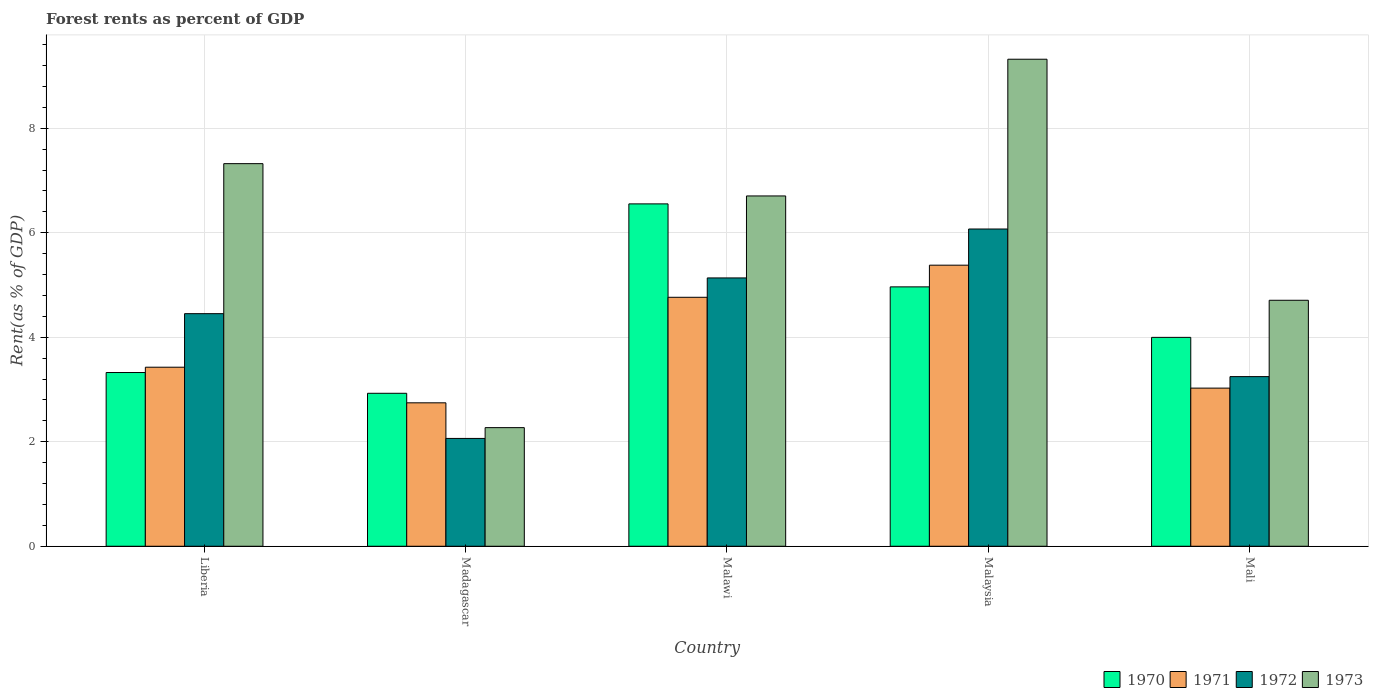Are the number of bars per tick equal to the number of legend labels?
Provide a short and direct response. Yes. What is the label of the 3rd group of bars from the left?
Provide a succinct answer. Malawi. What is the forest rent in 1970 in Madagascar?
Your response must be concise. 2.93. Across all countries, what is the maximum forest rent in 1972?
Provide a succinct answer. 6.07. Across all countries, what is the minimum forest rent in 1970?
Offer a very short reply. 2.93. In which country was the forest rent in 1970 maximum?
Keep it short and to the point. Malawi. In which country was the forest rent in 1973 minimum?
Give a very brief answer. Madagascar. What is the total forest rent in 1972 in the graph?
Ensure brevity in your answer.  20.97. What is the difference between the forest rent in 1972 in Liberia and that in Malaysia?
Provide a short and direct response. -1.62. What is the difference between the forest rent in 1972 in Liberia and the forest rent in 1971 in Malaysia?
Your response must be concise. -0.93. What is the average forest rent in 1971 per country?
Offer a terse response. 3.87. What is the difference between the forest rent of/in 1973 and forest rent of/in 1972 in Malaysia?
Offer a terse response. 3.25. In how many countries, is the forest rent in 1971 greater than 3.2 %?
Ensure brevity in your answer.  3. What is the ratio of the forest rent in 1972 in Madagascar to that in Malaysia?
Your answer should be very brief. 0.34. What is the difference between the highest and the second highest forest rent in 1973?
Give a very brief answer. 2.62. What is the difference between the highest and the lowest forest rent in 1971?
Your answer should be compact. 2.63. In how many countries, is the forest rent in 1972 greater than the average forest rent in 1972 taken over all countries?
Keep it short and to the point. 3. Is the sum of the forest rent in 1970 in Liberia and Madagascar greater than the maximum forest rent in 1973 across all countries?
Keep it short and to the point. No. Is it the case that in every country, the sum of the forest rent in 1971 and forest rent in 1970 is greater than the sum of forest rent in 1973 and forest rent in 1972?
Ensure brevity in your answer.  No. What does the 3rd bar from the left in Malawi represents?
Your response must be concise. 1972. Is it the case that in every country, the sum of the forest rent in 1973 and forest rent in 1970 is greater than the forest rent in 1971?
Your response must be concise. Yes. How many countries are there in the graph?
Provide a short and direct response. 5. What is the difference between two consecutive major ticks on the Y-axis?
Make the answer very short. 2. Are the values on the major ticks of Y-axis written in scientific E-notation?
Your answer should be compact. No. Does the graph contain any zero values?
Provide a succinct answer. No. How many legend labels are there?
Your answer should be compact. 4. How are the legend labels stacked?
Keep it short and to the point. Horizontal. What is the title of the graph?
Offer a terse response. Forest rents as percent of GDP. Does "1982" appear as one of the legend labels in the graph?
Your response must be concise. No. What is the label or title of the X-axis?
Your response must be concise. Country. What is the label or title of the Y-axis?
Your answer should be very brief. Rent(as % of GDP). What is the Rent(as % of GDP) in 1970 in Liberia?
Provide a short and direct response. 3.33. What is the Rent(as % of GDP) of 1971 in Liberia?
Give a very brief answer. 3.43. What is the Rent(as % of GDP) in 1972 in Liberia?
Ensure brevity in your answer.  4.45. What is the Rent(as % of GDP) in 1973 in Liberia?
Your response must be concise. 7.32. What is the Rent(as % of GDP) in 1970 in Madagascar?
Your answer should be very brief. 2.93. What is the Rent(as % of GDP) of 1971 in Madagascar?
Ensure brevity in your answer.  2.75. What is the Rent(as % of GDP) of 1972 in Madagascar?
Offer a terse response. 2.06. What is the Rent(as % of GDP) in 1973 in Madagascar?
Your answer should be compact. 2.27. What is the Rent(as % of GDP) in 1970 in Malawi?
Ensure brevity in your answer.  6.55. What is the Rent(as % of GDP) of 1971 in Malawi?
Give a very brief answer. 4.77. What is the Rent(as % of GDP) of 1972 in Malawi?
Offer a terse response. 5.14. What is the Rent(as % of GDP) in 1973 in Malawi?
Offer a very short reply. 6.71. What is the Rent(as % of GDP) of 1970 in Malaysia?
Make the answer very short. 4.96. What is the Rent(as % of GDP) in 1971 in Malaysia?
Your response must be concise. 5.38. What is the Rent(as % of GDP) in 1972 in Malaysia?
Your response must be concise. 6.07. What is the Rent(as % of GDP) in 1973 in Malaysia?
Give a very brief answer. 9.32. What is the Rent(as % of GDP) in 1970 in Mali?
Give a very brief answer. 4. What is the Rent(as % of GDP) in 1971 in Mali?
Keep it short and to the point. 3.03. What is the Rent(as % of GDP) in 1972 in Mali?
Your answer should be very brief. 3.25. What is the Rent(as % of GDP) of 1973 in Mali?
Make the answer very short. 4.71. Across all countries, what is the maximum Rent(as % of GDP) of 1970?
Keep it short and to the point. 6.55. Across all countries, what is the maximum Rent(as % of GDP) in 1971?
Keep it short and to the point. 5.38. Across all countries, what is the maximum Rent(as % of GDP) in 1972?
Your response must be concise. 6.07. Across all countries, what is the maximum Rent(as % of GDP) in 1973?
Keep it short and to the point. 9.32. Across all countries, what is the minimum Rent(as % of GDP) in 1970?
Your answer should be compact. 2.93. Across all countries, what is the minimum Rent(as % of GDP) of 1971?
Your answer should be compact. 2.75. Across all countries, what is the minimum Rent(as % of GDP) in 1972?
Provide a succinct answer. 2.06. Across all countries, what is the minimum Rent(as % of GDP) of 1973?
Give a very brief answer. 2.27. What is the total Rent(as % of GDP) in 1970 in the graph?
Provide a short and direct response. 21.77. What is the total Rent(as % of GDP) in 1971 in the graph?
Offer a very short reply. 19.34. What is the total Rent(as % of GDP) of 1972 in the graph?
Offer a terse response. 20.97. What is the total Rent(as % of GDP) of 1973 in the graph?
Give a very brief answer. 30.33. What is the difference between the Rent(as % of GDP) of 1970 in Liberia and that in Madagascar?
Your answer should be compact. 0.4. What is the difference between the Rent(as % of GDP) of 1971 in Liberia and that in Madagascar?
Offer a terse response. 0.68. What is the difference between the Rent(as % of GDP) in 1972 in Liberia and that in Madagascar?
Offer a very short reply. 2.39. What is the difference between the Rent(as % of GDP) of 1973 in Liberia and that in Madagascar?
Give a very brief answer. 5.05. What is the difference between the Rent(as % of GDP) in 1970 in Liberia and that in Malawi?
Your answer should be very brief. -3.23. What is the difference between the Rent(as % of GDP) of 1971 in Liberia and that in Malawi?
Ensure brevity in your answer.  -1.34. What is the difference between the Rent(as % of GDP) in 1972 in Liberia and that in Malawi?
Provide a succinct answer. -0.68. What is the difference between the Rent(as % of GDP) in 1973 in Liberia and that in Malawi?
Provide a short and direct response. 0.62. What is the difference between the Rent(as % of GDP) of 1970 in Liberia and that in Malaysia?
Keep it short and to the point. -1.64. What is the difference between the Rent(as % of GDP) in 1971 in Liberia and that in Malaysia?
Offer a terse response. -1.95. What is the difference between the Rent(as % of GDP) of 1972 in Liberia and that in Malaysia?
Your response must be concise. -1.62. What is the difference between the Rent(as % of GDP) in 1973 in Liberia and that in Malaysia?
Your response must be concise. -2. What is the difference between the Rent(as % of GDP) in 1970 in Liberia and that in Mali?
Give a very brief answer. -0.67. What is the difference between the Rent(as % of GDP) in 1971 in Liberia and that in Mali?
Your answer should be compact. 0.4. What is the difference between the Rent(as % of GDP) in 1972 in Liberia and that in Mali?
Your response must be concise. 1.21. What is the difference between the Rent(as % of GDP) of 1973 in Liberia and that in Mali?
Your response must be concise. 2.62. What is the difference between the Rent(as % of GDP) of 1970 in Madagascar and that in Malawi?
Offer a very short reply. -3.63. What is the difference between the Rent(as % of GDP) of 1971 in Madagascar and that in Malawi?
Your answer should be compact. -2.02. What is the difference between the Rent(as % of GDP) of 1972 in Madagascar and that in Malawi?
Your answer should be compact. -3.07. What is the difference between the Rent(as % of GDP) in 1973 in Madagascar and that in Malawi?
Provide a succinct answer. -4.43. What is the difference between the Rent(as % of GDP) in 1970 in Madagascar and that in Malaysia?
Ensure brevity in your answer.  -2.04. What is the difference between the Rent(as % of GDP) of 1971 in Madagascar and that in Malaysia?
Provide a short and direct response. -2.63. What is the difference between the Rent(as % of GDP) in 1972 in Madagascar and that in Malaysia?
Offer a very short reply. -4.01. What is the difference between the Rent(as % of GDP) of 1973 in Madagascar and that in Malaysia?
Keep it short and to the point. -7.05. What is the difference between the Rent(as % of GDP) of 1970 in Madagascar and that in Mali?
Offer a very short reply. -1.07. What is the difference between the Rent(as % of GDP) of 1971 in Madagascar and that in Mali?
Offer a very short reply. -0.28. What is the difference between the Rent(as % of GDP) in 1972 in Madagascar and that in Mali?
Your answer should be compact. -1.18. What is the difference between the Rent(as % of GDP) in 1973 in Madagascar and that in Mali?
Keep it short and to the point. -2.44. What is the difference between the Rent(as % of GDP) of 1970 in Malawi and that in Malaysia?
Make the answer very short. 1.59. What is the difference between the Rent(as % of GDP) in 1971 in Malawi and that in Malaysia?
Provide a succinct answer. -0.61. What is the difference between the Rent(as % of GDP) in 1972 in Malawi and that in Malaysia?
Provide a succinct answer. -0.94. What is the difference between the Rent(as % of GDP) in 1973 in Malawi and that in Malaysia?
Make the answer very short. -2.62. What is the difference between the Rent(as % of GDP) of 1970 in Malawi and that in Mali?
Offer a terse response. 2.55. What is the difference between the Rent(as % of GDP) in 1971 in Malawi and that in Mali?
Offer a terse response. 1.74. What is the difference between the Rent(as % of GDP) of 1972 in Malawi and that in Mali?
Give a very brief answer. 1.89. What is the difference between the Rent(as % of GDP) in 1973 in Malawi and that in Mali?
Keep it short and to the point. 2. What is the difference between the Rent(as % of GDP) of 1970 in Malaysia and that in Mali?
Give a very brief answer. 0.97. What is the difference between the Rent(as % of GDP) in 1971 in Malaysia and that in Mali?
Provide a short and direct response. 2.35. What is the difference between the Rent(as % of GDP) in 1972 in Malaysia and that in Mali?
Ensure brevity in your answer.  2.83. What is the difference between the Rent(as % of GDP) in 1973 in Malaysia and that in Mali?
Provide a succinct answer. 4.61. What is the difference between the Rent(as % of GDP) of 1970 in Liberia and the Rent(as % of GDP) of 1971 in Madagascar?
Your answer should be compact. 0.58. What is the difference between the Rent(as % of GDP) in 1970 in Liberia and the Rent(as % of GDP) in 1972 in Madagascar?
Make the answer very short. 1.26. What is the difference between the Rent(as % of GDP) in 1970 in Liberia and the Rent(as % of GDP) in 1973 in Madagascar?
Provide a short and direct response. 1.05. What is the difference between the Rent(as % of GDP) in 1971 in Liberia and the Rent(as % of GDP) in 1972 in Madagascar?
Provide a succinct answer. 1.36. What is the difference between the Rent(as % of GDP) of 1971 in Liberia and the Rent(as % of GDP) of 1973 in Madagascar?
Your answer should be compact. 1.16. What is the difference between the Rent(as % of GDP) in 1972 in Liberia and the Rent(as % of GDP) in 1973 in Madagascar?
Provide a succinct answer. 2.18. What is the difference between the Rent(as % of GDP) of 1970 in Liberia and the Rent(as % of GDP) of 1971 in Malawi?
Provide a short and direct response. -1.44. What is the difference between the Rent(as % of GDP) of 1970 in Liberia and the Rent(as % of GDP) of 1972 in Malawi?
Your response must be concise. -1.81. What is the difference between the Rent(as % of GDP) of 1970 in Liberia and the Rent(as % of GDP) of 1973 in Malawi?
Your response must be concise. -3.38. What is the difference between the Rent(as % of GDP) of 1971 in Liberia and the Rent(as % of GDP) of 1972 in Malawi?
Offer a very short reply. -1.71. What is the difference between the Rent(as % of GDP) of 1971 in Liberia and the Rent(as % of GDP) of 1973 in Malawi?
Provide a succinct answer. -3.28. What is the difference between the Rent(as % of GDP) in 1972 in Liberia and the Rent(as % of GDP) in 1973 in Malawi?
Your answer should be compact. -2.25. What is the difference between the Rent(as % of GDP) of 1970 in Liberia and the Rent(as % of GDP) of 1971 in Malaysia?
Keep it short and to the point. -2.05. What is the difference between the Rent(as % of GDP) in 1970 in Liberia and the Rent(as % of GDP) in 1972 in Malaysia?
Offer a terse response. -2.75. What is the difference between the Rent(as % of GDP) of 1970 in Liberia and the Rent(as % of GDP) of 1973 in Malaysia?
Keep it short and to the point. -6. What is the difference between the Rent(as % of GDP) in 1971 in Liberia and the Rent(as % of GDP) in 1972 in Malaysia?
Provide a succinct answer. -2.65. What is the difference between the Rent(as % of GDP) of 1971 in Liberia and the Rent(as % of GDP) of 1973 in Malaysia?
Provide a succinct answer. -5.89. What is the difference between the Rent(as % of GDP) in 1972 in Liberia and the Rent(as % of GDP) in 1973 in Malaysia?
Give a very brief answer. -4.87. What is the difference between the Rent(as % of GDP) in 1970 in Liberia and the Rent(as % of GDP) in 1971 in Mali?
Ensure brevity in your answer.  0.3. What is the difference between the Rent(as % of GDP) in 1970 in Liberia and the Rent(as % of GDP) in 1972 in Mali?
Your answer should be very brief. 0.08. What is the difference between the Rent(as % of GDP) of 1970 in Liberia and the Rent(as % of GDP) of 1973 in Mali?
Your answer should be compact. -1.38. What is the difference between the Rent(as % of GDP) of 1971 in Liberia and the Rent(as % of GDP) of 1972 in Mali?
Provide a succinct answer. 0.18. What is the difference between the Rent(as % of GDP) in 1971 in Liberia and the Rent(as % of GDP) in 1973 in Mali?
Your answer should be very brief. -1.28. What is the difference between the Rent(as % of GDP) in 1972 in Liberia and the Rent(as % of GDP) in 1973 in Mali?
Give a very brief answer. -0.26. What is the difference between the Rent(as % of GDP) of 1970 in Madagascar and the Rent(as % of GDP) of 1971 in Malawi?
Provide a short and direct response. -1.84. What is the difference between the Rent(as % of GDP) in 1970 in Madagascar and the Rent(as % of GDP) in 1972 in Malawi?
Your answer should be very brief. -2.21. What is the difference between the Rent(as % of GDP) of 1970 in Madagascar and the Rent(as % of GDP) of 1973 in Malawi?
Provide a short and direct response. -3.78. What is the difference between the Rent(as % of GDP) of 1971 in Madagascar and the Rent(as % of GDP) of 1972 in Malawi?
Your answer should be very brief. -2.39. What is the difference between the Rent(as % of GDP) of 1971 in Madagascar and the Rent(as % of GDP) of 1973 in Malawi?
Give a very brief answer. -3.96. What is the difference between the Rent(as % of GDP) of 1972 in Madagascar and the Rent(as % of GDP) of 1973 in Malawi?
Offer a very short reply. -4.64. What is the difference between the Rent(as % of GDP) in 1970 in Madagascar and the Rent(as % of GDP) in 1971 in Malaysia?
Provide a short and direct response. -2.45. What is the difference between the Rent(as % of GDP) of 1970 in Madagascar and the Rent(as % of GDP) of 1972 in Malaysia?
Your answer should be very brief. -3.14. What is the difference between the Rent(as % of GDP) in 1970 in Madagascar and the Rent(as % of GDP) in 1973 in Malaysia?
Make the answer very short. -6.39. What is the difference between the Rent(as % of GDP) in 1971 in Madagascar and the Rent(as % of GDP) in 1972 in Malaysia?
Ensure brevity in your answer.  -3.33. What is the difference between the Rent(as % of GDP) of 1971 in Madagascar and the Rent(as % of GDP) of 1973 in Malaysia?
Offer a terse response. -6.58. What is the difference between the Rent(as % of GDP) in 1972 in Madagascar and the Rent(as % of GDP) in 1973 in Malaysia?
Ensure brevity in your answer.  -7.26. What is the difference between the Rent(as % of GDP) in 1970 in Madagascar and the Rent(as % of GDP) in 1971 in Mali?
Your answer should be very brief. -0.1. What is the difference between the Rent(as % of GDP) in 1970 in Madagascar and the Rent(as % of GDP) in 1972 in Mali?
Your answer should be very brief. -0.32. What is the difference between the Rent(as % of GDP) of 1970 in Madagascar and the Rent(as % of GDP) of 1973 in Mali?
Provide a succinct answer. -1.78. What is the difference between the Rent(as % of GDP) in 1971 in Madagascar and the Rent(as % of GDP) in 1972 in Mali?
Offer a terse response. -0.5. What is the difference between the Rent(as % of GDP) of 1971 in Madagascar and the Rent(as % of GDP) of 1973 in Mali?
Provide a succinct answer. -1.96. What is the difference between the Rent(as % of GDP) of 1972 in Madagascar and the Rent(as % of GDP) of 1973 in Mali?
Offer a terse response. -2.64. What is the difference between the Rent(as % of GDP) in 1970 in Malawi and the Rent(as % of GDP) in 1971 in Malaysia?
Keep it short and to the point. 1.17. What is the difference between the Rent(as % of GDP) of 1970 in Malawi and the Rent(as % of GDP) of 1972 in Malaysia?
Keep it short and to the point. 0.48. What is the difference between the Rent(as % of GDP) in 1970 in Malawi and the Rent(as % of GDP) in 1973 in Malaysia?
Your response must be concise. -2.77. What is the difference between the Rent(as % of GDP) of 1971 in Malawi and the Rent(as % of GDP) of 1972 in Malaysia?
Provide a short and direct response. -1.31. What is the difference between the Rent(as % of GDP) in 1971 in Malawi and the Rent(as % of GDP) in 1973 in Malaysia?
Your answer should be very brief. -4.56. What is the difference between the Rent(as % of GDP) in 1972 in Malawi and the Rent(as % of GDP) in 1973 in Malaysia?
Give a very brief answer. -4.19. What is the difference between the Rent(as % of GDP) in 1970 in Malawi and the Rent(as % of GDP) in 1971 in Mali?
Your response must be concise. 3.53. What is the difference between the Rent(as % of GDP) in 1970 in Malawi and the Rent(as % of GDP) in 1972 in Mali?
Keep it short and to the point. 3.31. What is the difference between the Rent(as % of GDP) of 1970 in Malawi and the Rent(as % of GDP) of 1973 in Mali?
Your answer should be very brief. 1.84. What is the difference between the Rent(as % of GDP) in 1971 in Malawi and the Rent(as % of GDP) in 1972 in Mali?
Ensure brevity in your answer.  1.52. What is the difference between the Rent(as % of GDP) in 1971 in Malawi and the Rent(as % of GDP) in 1973 in Mali?
Your response must be concise. 0.06. What is the difference between the Rent(as % of GDP) of 1972 in Malawi and the Rent(as % of GDP) of 1973 in Mali?
Make the answer very short. 0.43. What is the difference between the Rent(as % of GDP) of 1970 in Malaysia and the Rent(as % of GDP) of 1971 in Mali?
Make the answer very short. 1.94. What is the difference between the Rent(as % of GDP) of 1970 in Malaysia and the Rent(as % of GDP) of 1972 in Mali?
Provide a short and direct response. 1.72. What is the difference between the Rent(as % of GDP) in 1970 in Malaysia and the Rent(as % of GDP) in 1973 in Mali?
Provide a succinct answer. 0.26. What is the difference between the Rent(as % of GDP) of 1971 in Malaysia and the Rent(as % of GDP) of 1972 in Mali?
Offer a terse response. 2.13. What is the difference between the Rent(as % of GDP) in 1971 in Malaysia and the Rent(as % of GDP) in 1973 in Mali?
Provide a short and direct response. 0.67. What is the difference between the Rent(as % of GDP) of 1972 in Malaysia and the Rent(as % of GDP) of 1973 in Mali?
Provide a short and direct response. 1.36. What is the average Rent(as % of GDP) of 1970 per country?
Ensure brevity in your answer.  4.35. What is the average Rent(as % of GDP) in 1971 per country?
Provide a succinct answer. 3.87. What is the average Rent(as % of GDP) of 1972 per country?
Offer a very short reply. 4.19. What is the average Rent(as % of GDP) of 1973 per country?
Ensure brevity in your answer.  6.07. What is the difference between the Rent(as % of GDP) of 1970 and Rent(as % of GDP) of 1971 in Liberia?
Offer a very short reply. -0.1. What is the difference between the Rent(as % of GDP) of 1970 and Rent(as % of GDP) of 1972 in Liberia?
Make the answer very short. -1.13. What is the difference between the Rent(as % of GDP) of 1970 and Rent(as % of GDP) of 1973 in Liberia?
Provide a succinct answer. -4. What is the difference between the Rent(as % of GDP) in 1971 and Rent(as % of GDP) in 1972 in Liberia?
Make the answer very short. -1.02. What is the difference between the Rent(as % of GDP) of 1971 and Rent(as % of GDP) of 1973 in Liberia?
Give a very brief answer. -3.9. What is the difference between the Rent(as % of GDP) of 1972 and Rent(as % of GDP) of 1973 in Liberia?
Offer a terse response. -2.87. What is the difference between the Rent(as % of GDP) of 1970 and Rent(as % of GDP) of 1971 in Madagascar?
Give a very brief answer. 0.18. What is the difference between the Rent(as % of GDP) in 1970 and Rent(as % of GDP) in 1972 in Madagascar?
Your answer should be compact. 0.86. What is the difference between the Rent(as % of GDP) of 1970 and Rent(as % of GDP) of 1973 in Madagascar?
Keep it short and to the point. 0.66. What is the difference between the Rent(as % of GDP) of 1971 and Rent(as % of GDP) of 1972 in Madagascar?
Keep it short and to the point. 0.68. What is the difference between the Rent(as % of GDP) of 1971 and Rent(as % of GDP) of 1973 in Madagascar?
Provide a succinct answer. 0.47. What is the difference between the Rent(as % of GDP) in 1972 and Rent(as % of GDP) in 1973 in Madagascar?
Your answer should be very brief. -0.21. What is the difference between the Rent(as % of GDP) of 1970 and Rent(as % of GDP) of 1971 in Malawi?
Your response must be concise. 1.79. What is the difference between the Rent(as % of GDP) in 1970 and Rent(as % of GDP) in 1972 in Malawi?
Give a very brief answer. 1.42. What is the difference between the Rent(as % of GDP) in 1970 and Rent(as % of GDP) in 1973 in Malawi?
Provide a succinct answer. -0.15. What is the difference between the Rent(as % of GDP) in 1971 and Rent(as % of GDP) in 1972 in Malawi?
Your answer should be compact. -0.37. What is the difference between the Rent(as % of GDP) in 1971 and Rent(as % of GDP) in 1973 in Malawi?
Offer a terse response. -1.94. What is the difference between the Rent(as % of GDP) of 1972 and Rent(as % of GDP) of 1973 in Malawi?
Your response must be concise. -1.57. What is the difference between the Rent(as % of GDP) in 1970 and Rent(as % of GDP) in 1971 in Malaysia?
Offer a very short reply. -0.42. What is the difference between the Rent(as % of GDP) of 1970 and Rent(as % of GDP) of 1972 in Malaysia?
Provide a succinct answer. -1.11. What is the difference between the Rent(as % of GDP) of 1970 and Rent(as % of GDP) of 1973 in Malaysia?
Your answer should be very brief. -4.36. What is the difference between the Rent(as % of GDP) in 1971 and Rent(as % of GDP) in 1972 in Malaysia?
Keep it short and to the point. -0.69. What is the difference between the Rent(as % of GDP) of 1971 and Rent(as % of GDP) of 1973 in Malaysia?
Your answer should be compact. -3.94. What is the difference between the Rent(as % of GDP) in 1972 and Rent(as % of GDP) in 1973 in Malaysia?
Make the answer very short. -3.25. What is the difference between the Rent(as % of GDP) of 1970 and Rent(as % of GDP) of 1971 in Mali?
Ensure brevity in your answer.  0.97. What is the difference between the Rent(as % of GDP) of 1970 and Rent(as % of GDP) of 1972 in Mali?
Provide a succinct answer. 0.75. What is the difference between the Rent(as % of GDP) in 1970 and Rent(as % of GDP) in 1973 in Mali?
Your answer should be very brief. -0.71. What is the difference between the Rent(as % of GDP) in 1971 and Rent(as % of GDP) in 1972 in Mali?
Keep it short and to the point. -0.22. What is the difference between the Rent(as % of GDP) in 1971 and Rent(as % of GDP) in 1973 in Mali?
Give a very brief answer. -1.68. What is the difference between the Rent(as % of GDP) of 1972 and Rent(as % of GDP) of 1973 in Mali?
Keep it short and to the point. -1.46. What is the ratio of the Rent(as % of GDP) of 1970 in Liberia to that in Madagascar?
Offer a very short reply. 1.14. What is the ratio of the Rent(as % of GDP) of 1971 in Liberia to that in Madagascar?
Your answer should be compact. 1.25. What is the ratio of the Rent(as % of GDP) in 1972 in Liberia to that in Madagascar?
Your response must be concise. 2.16. What is the ratio of the Rent(as % of GDP) in 1973 in Liberia to that in Madagascar?
Your answer should be compact. 3.23. What is the ratio of the Rent(as % of GDP) in 1970 in Liberia to that in Malawi?
Your answer should be compact. 0.51. What is the ratio of the Rent(as % of GDP) in 1971 in Liberia to that in Malawi?
Offer a very short reply. 0.72. What is the ratio of the Rent(as % of GDP) in 1972 in Liberia to that in Malawi?
Ensure brevity in your answer.  0.87. What is the ratio of the Rent(as % of GDP) of 1973 in Liberia to that in Malawi?
Provide a short and direct response. 1.09. What is the ratio of the Rent(as % of GDP) of 1970 in Liberia to that in Malaysia?
Provide a short and direct response. 0.67. What is the ratio of the Rent(as % of GDP) in 1971 in Liberia to that in Malaysia?
Offer a terse response. 0.64. What is the ratio of the Rent(as % of GDP) in 1972 in Liberia to that in Malaysia?
Your answer should be very brief. 0.73. What is the ratio of the Rent(as % of GDP) in 1973 in Liberia to that in Malaysia?
Ensure brevity in your answer.  0.79. What is the ratio of the Rent(as % of GDP) in 1970 in Liberia to that in Mali?
Give a very brief answer. 0.83. What is the ratio of the Rent(as % of GDP) of 1971 in Liberia to that in Mali?
Keep it short and to the point. 1.13. What is the ratio of the Rent(as % of GDP) of 1972 in Liberia to that in Mali?
Offer a terse response. 1.37. What is the ratio of the Rent(as % of GDP) in 1973 in Liberia to that in Mali?
Give a very brief answer. 1.56. What is the ratio of the Rent(as % of GDP) of 1970 in Madagascar to that in Malawi?
Give a very brief answer. 0.45. What is the ratio of the Rent(as % of GDP) in 1971 in Madagascar to that in Malawi?
Make the answer very short. 0.58. What is the ratio of the Rent(as % of GDP) in 1972 in Madagascar to that in Malawi?
Keep it short and to the point. 0.4. What is the ratio of the Rent(as % of GDP) in 1973 in Madagascar to that in Malawi?
Offer a very short reply. 0.34. What is the ratio of the Rent(as % of GDP) in 1970 in Madagascar to that in Malaysia?
Offer a very short reply. 0.59. What is the ratio of the Rent(as % of GDP) of 1971 in Madagascar to that in Malaysia?
Offer a very short reply. 0.51. What is the ratio of the Rent(as % of GDP) of 1972 in Madagascar to that in Malaysia?
Offer a terse response. 0.34. What is the ratio of the Rent(as % of GDP) in 1973 in Madagascar to that in Malaysia?
Provide a short and direct response. 0.24. What is the ratio of the Rent(as % of GDP) of 1970 in Madagascar to that in Mali?
Ensure brevity in your answer.  0.73. What is the ratio of the Rent(as % of GDP) of 1971 in Madagascar to that in Mali?
Ensure brevity in your answer.  0.91. What is the ratio of the Rent(as % of GDP) in 1972 in Madagascar to that in Mali?
Your answer should be very brief. 0.64. What is the ratio of the Rent(as % of GDP) in 1973 in Madagascar to that in Mali?
Give a very brief answer. 0.48. What is the ratio of the Rent(as % of GDP) in 1970 in Malawi to that in Malaysia?
Your answer should be very brief. 1.32. What is the ratio of the Rent(as % of GDP) in 1971 in Malawi to that in Malaysia?
Offer a terse response. 0.89. What is the ratio of the Rent(as % of GDP) in 1972 in Malawi to that in Malaysia?
Keep it short and to the point. 0.85. What is the ratio of the Rent(as % of GDP) in 1973 in Malawi to that in Malaysia?
Make the answer very short. 0.72. What is the ratio of the Rent(as % of GDP) in 1970 in Malawi to that in Mali?
Your response must be concise. 1.64. What is the ratio of the Rent(as % of GDP) in 1971 in Malawi to that in Mali?
Your answer should be very brief. 1.57. What is the ratio of the Rent(as % of GDP) in 1972 in Malawi to that in Mali?
Keep it short and to the point. 1.58. What is the ratio of the Rent(as % of GDP) in 1973 in Malawi to that in Mali?
Offer a very short reply. 1.42. What is the ratio of the Rent(as % of GDP) of 1970 in Malaysia to that in Mali?
Provide a succinct answer. 1.24. What is the ratio of the Rent(as % of GDP) of 1971 in Malaysia to that in Mali?
Make the answer very short. 1.78. What is the ratio of the Rent(as % of GDP) of 1972 in Malaysia to that in Mali?
Your answer should be compact. 1.87. What is the ratio of the Rent(as % of GDP) of 1973 in Malaysia to that in Mali?
Give a very brief answer. 1.98. What is the difference between the highest and the second highest Rent(as % of GDP) in 1970?
Make the answer very short. 1.59. What is the difference between the highest and the second highest Rent(as % of GDP) in 1971?
Your answer should be very brief. 0.61. What is the difference between the highest and the second highest Rent(as % of GDP) in 1972?
Your answer should be compact. 0.94. What is the difference between the highest and the second highest Rent(as % of GDP) in 1973?
Provide a short and direct response. 2. What is the difference between the highest and the lowest Rent(as % of GDP) of 1970?
Give a very brief answer. 3.63. What is the difference between the highest and the lowest Rent(as % of GDP) of 1971?
Make the answer very short. 2.63. What is the difference between the highest and the lowest Rent(as % of GDP) in 1972?
Offer a terse response. 4.01. What is the difference between the highest and the lowest Rent(as % of GDP) of 1973?
Offer a terse response. 7.05. 